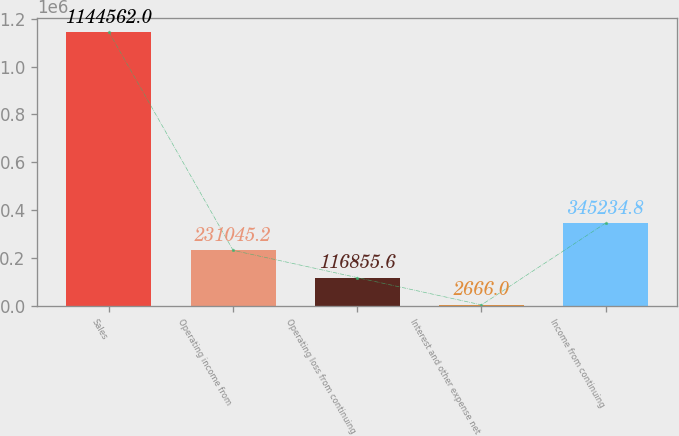<chart> <loc_0><loc_0><loc_500><loc_500><bar_chart><fcel>Sales<fcel>Operating income from<fcel>Operating loss from continuing<fcel>Interest and other expense net<fcel>Income from continuing<nl><fcel>1.14456e+06<fcel>231045<fcel>116856<fcel>2666<fcel>345235<nl></chart> 